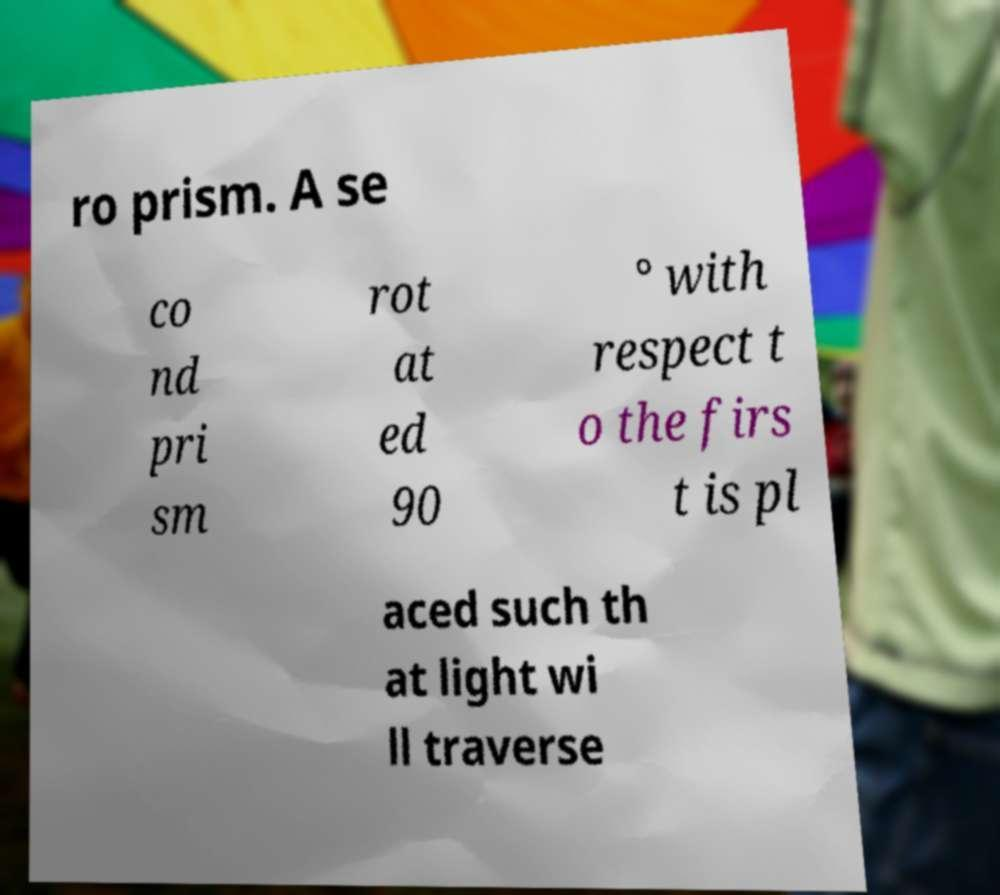There's text embedded in this image that I need extracted. Can you transcribe it verbatim? ro prism. A se co nd pri sm rot at ed 90 ° with respect t o the firs t is pl aced such th at light wi ll traverse 